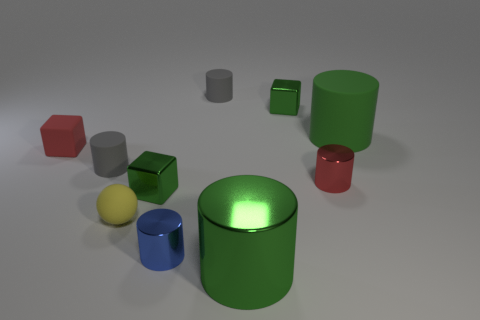Subtract all cylinders. How many objects are left? 4 Subtract all big green metallic cylinders. How many cylinders are left? 5 Subtract all tiny yellow spheres. Subtract all blue metallic things. How many objects are left? 8 Add 8 tiny yellow objects. How many tiny yellow objects are left? 9 Add 7 yellow spheres. How many yellow spheres exist? 8 Subtract all red cylinders. How many cylinders are left? 5 Subtract 0 brown spheres. How many objects are left? 10 Subtract 2 cubes. How many cubes are left? 1 Subtract all gray balls. Subtract all blue cylinders. How many balls are left? 1 Subtract all blue balls. How many gray cylinders are left? 2 